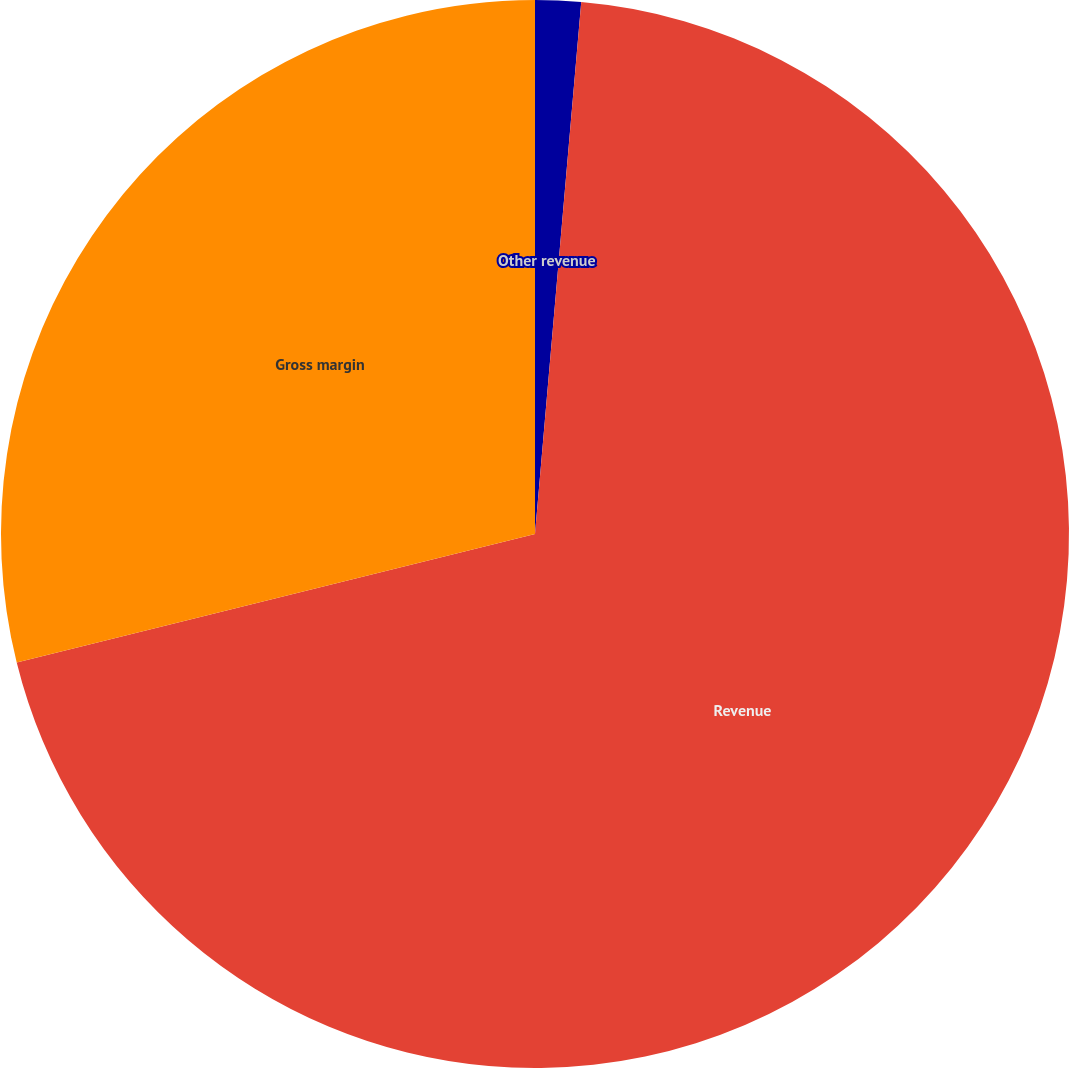Convert chart. <chart><loc_0><loc_0><loc_500><loc_500><pie_chart><fcel>Other revenue<fcel>Revenue<fcel>Gross margin<nl><fcel>1.38%<fcel>69.75%<fcel>28.87%<nl></chart> 